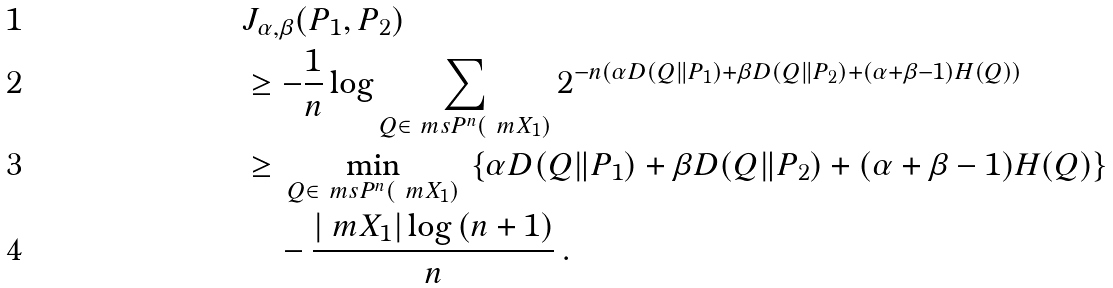<formula> <loc_0><loc_0><loc_500><loc_500>& J _ { \alpha , \beta } ( P _ { 1 } , P _ { 2 } ) \\ & \geq - \frac { 1 } { n } \log \sum _ { Q \in \ m s { P } ^ { n } ( \ m { X } _ { 1 } ) } 2 ^ { - n ( \alpha D ( Q \| P _ { 1 } ) + \beta D ( Q \| P _ { 2 } ) + ( \alpha + \beta - 1 ) H ( Q ) ) } \\ & \geq \, \min _ { Q \in \ m s { P } ^ { n } ( \ m { X } _ { 1 } ) } \, \left \{ \alpha D ( Q \| P _ { 1 } ) + \beta D ( Q \| P _ { 2 } ) + ( \alpha + \beta - 1 ) H ( Q ) \right \} \\ & \quad - \frac { | \ m { X } _ { 1 } | \log { ( n + 1 ) } } { n } \, .</formula> 